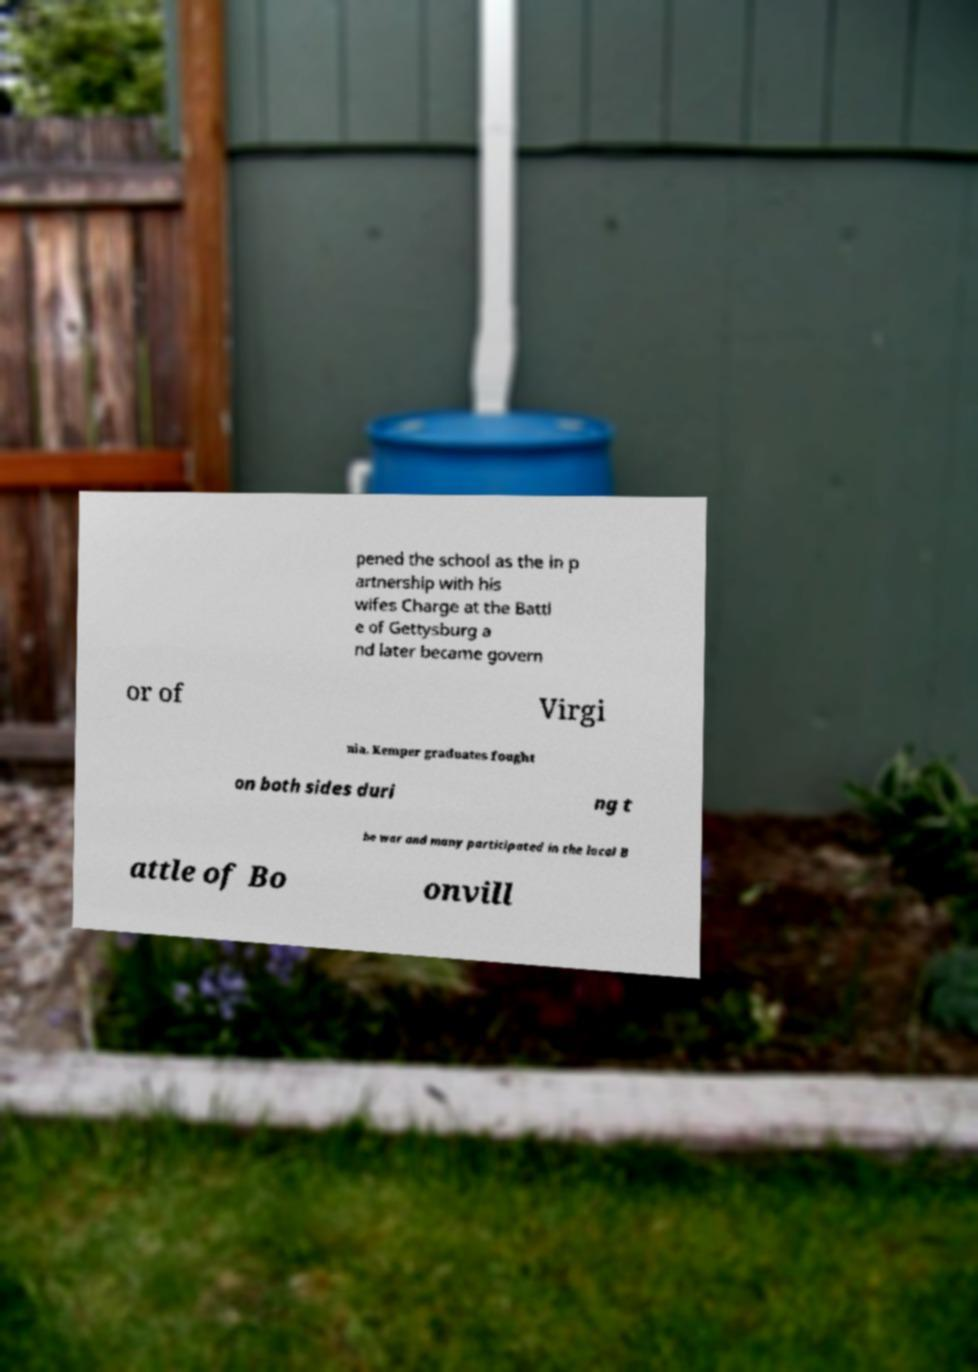Please identify and transcribe the text found in this image. pened the school as the in p artnership with his wifes Charge at the Battl e of Gettysburg a nd later became govern or of Virgi nia. Kemper graduates fought on both sides duri ng t he war and many participated in the local B attle of Bo onvill 